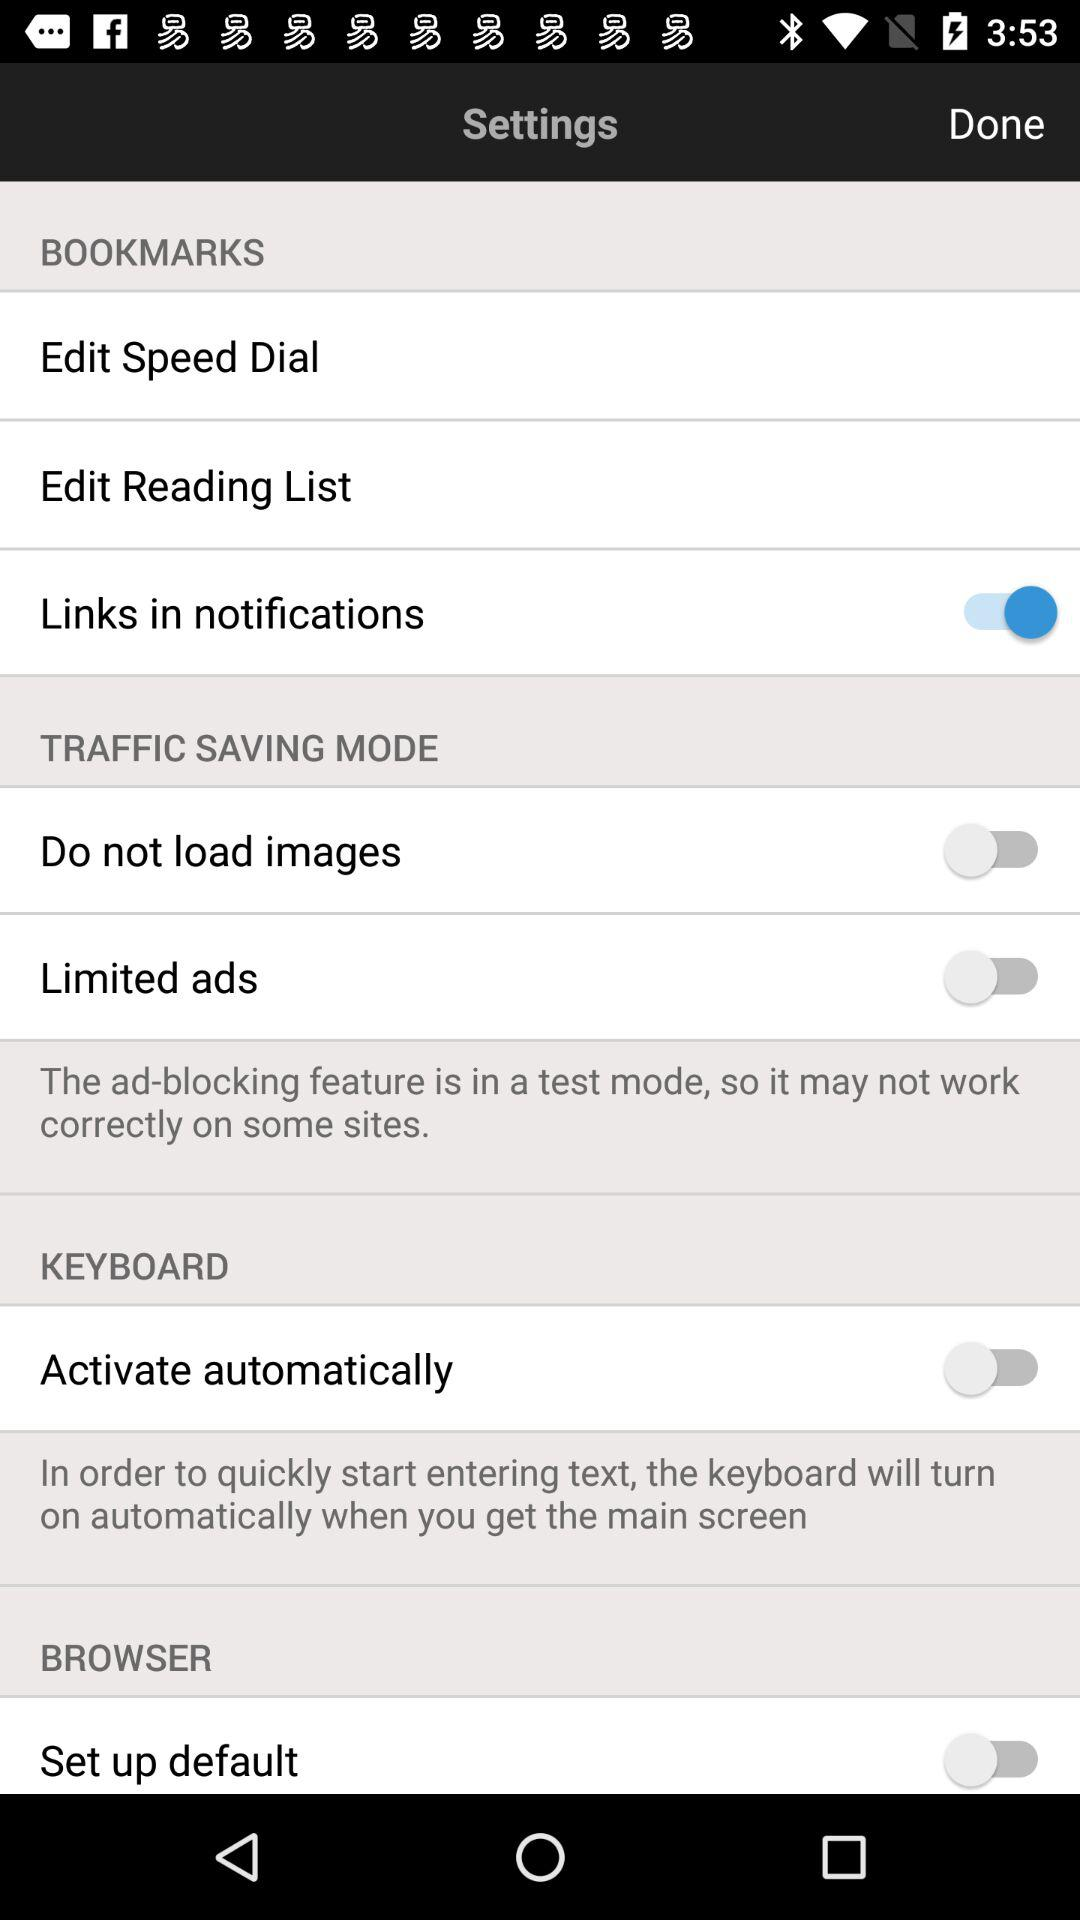What is the status of "Links in notifications"? The status of "Links in notifications" is "on". 